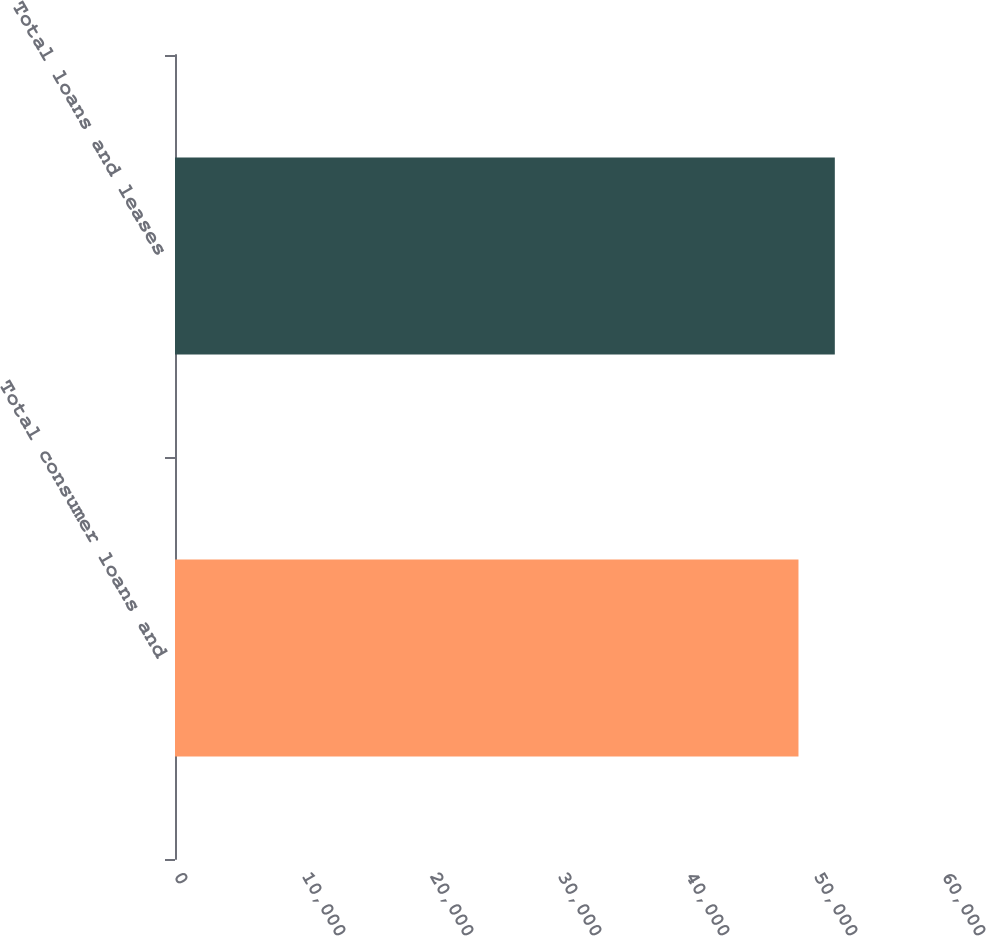Convert chart to OTSL. <chart><loc_0><loc_0><loc_500><loc_500><bar_chart><fcel>Total consumer loans and<fcel>Total loans and leases<nl><fcel>48709<fcel>51549<nl></chart> 